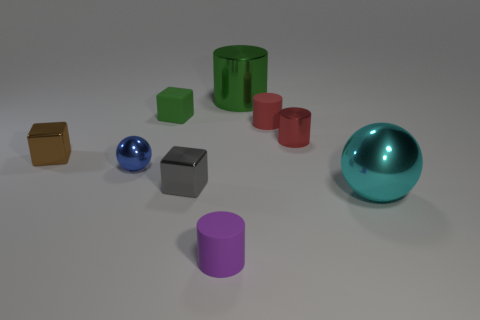There is a ball right of the tiny rubber thing in front of the large thing that is in front of the green matte thing; what is its size?
Give a very brief answer. Large. There is a cylinder that is the same color as the rubber cube; what is it made of?
Offer a terse response. Metal. Is there any other thing that is the same shape as the blue metal object?
Provide a short and direct response. Yes. There is a green thing to the left of the cylinder that is behind the red matte object; what size is it?
Offer a terse response. Small. What number of large things are either red balls or things?
Provide a succinct answer. 2. Is the number of small green matte balls less than the number of red rubber things?
Offer a terse response. Yes. Is there anything else that has the same size as the red matte cylinder?
Give a very brief answer. Yes. Does the small metal sphere have the same color as the big shiny sphere?
Make the answer very short. No. Is the number of large green cylinders greater than the number of yellow shiny cylinders?
Offer a very short reply. Yes. What number of other objects are the same color as the big ball?
Offer a very short reply. 0. 